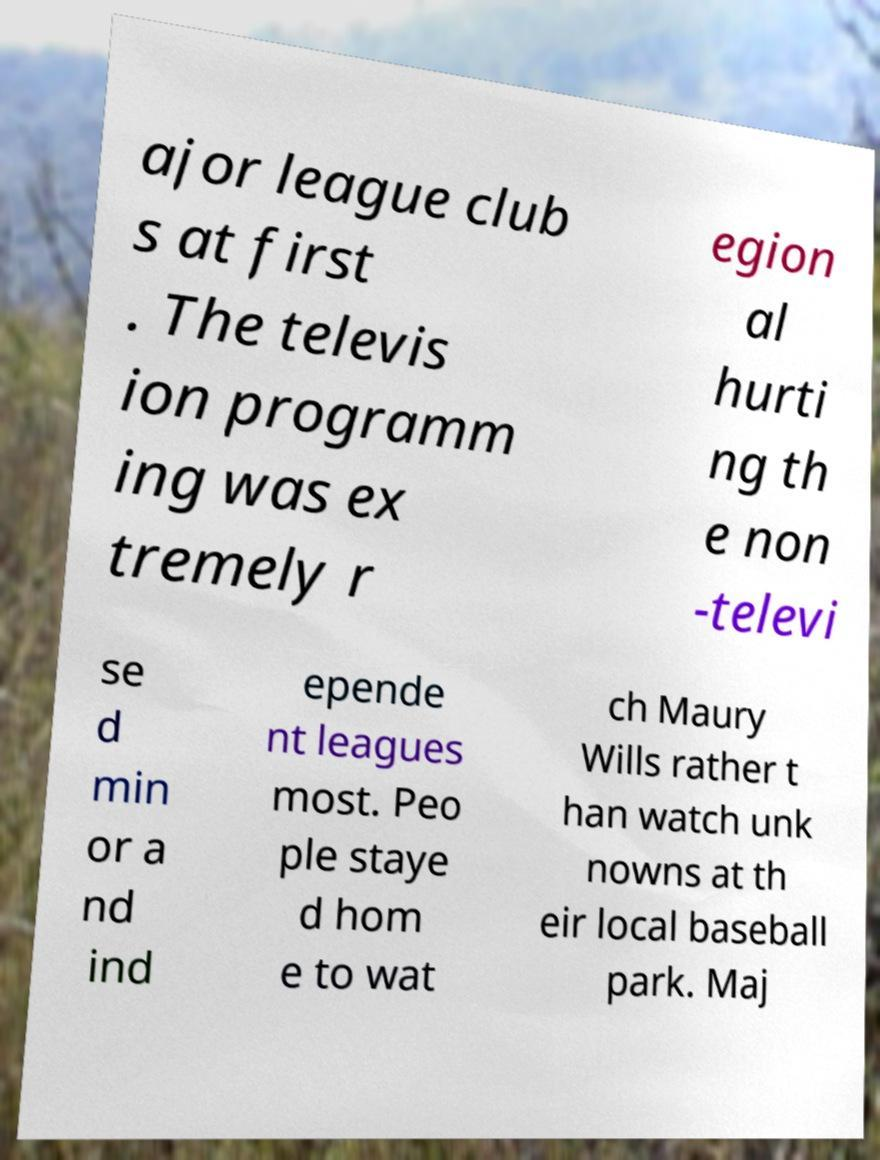Could you extract and type out the text from this image? ajor league club s at first . The televis ion programm ing was ex tremely r egion al hurti ng th e non -televi se d min or a nd ind epende nt leagues most. Peo ple staye d hom e to wat ch Maury Wills rather t han watch unk nowns at th eir local baseball park. Maj 